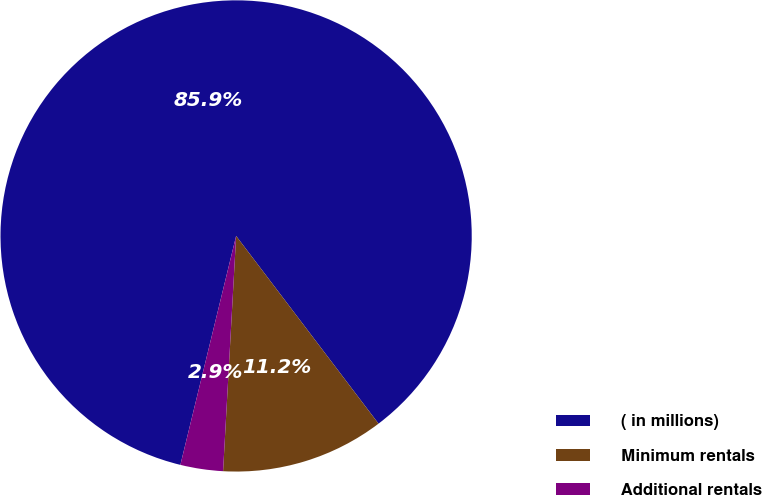<chart> <loc_0><loc_0><loc_500><loc_500><pie_chart><fcel>( in millions)<fcel>Minimum rentals<fcel>Additional rentals<nl><fcel>85.87%<fcel>11.21%<fcel>2.92%<nl></chart> 